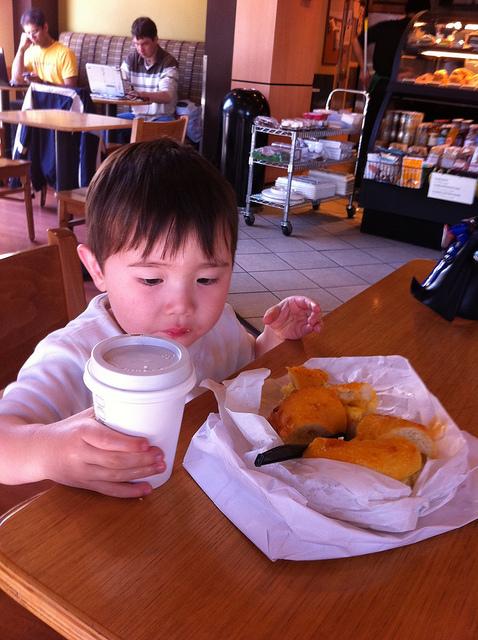How many laptops can be seen?
Write a very short answer. 2. Is the childs hair black?
Short answer required. Yes. Where is the child sitting?
Keep it brief. In chair. 